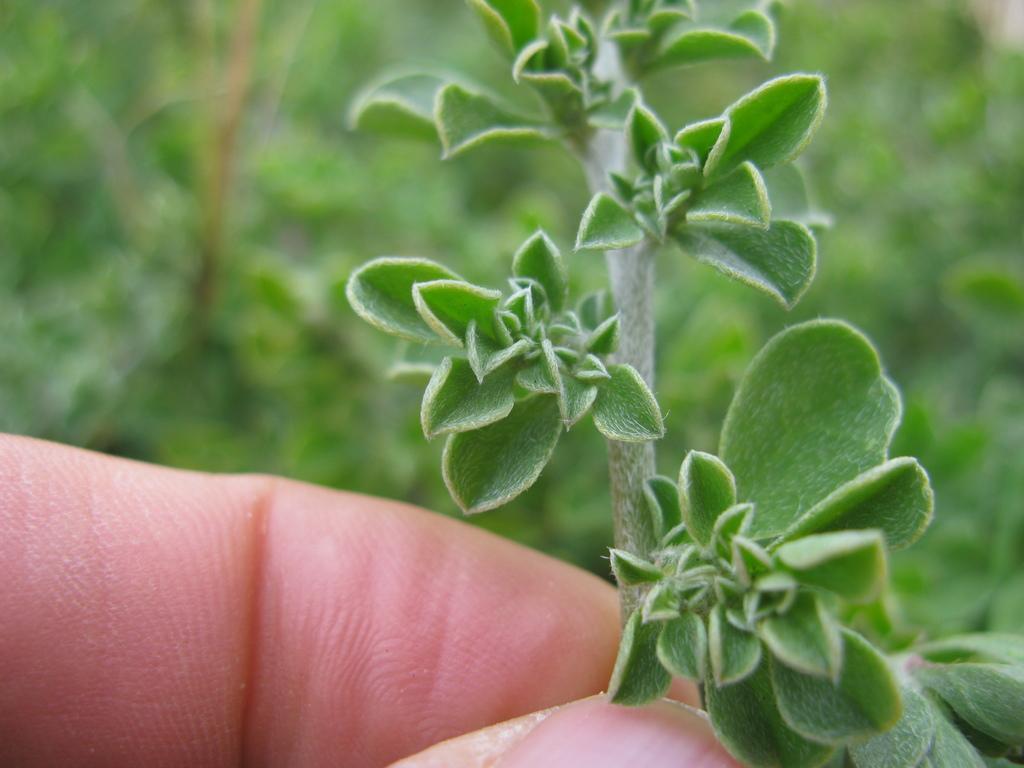Describe this image in one or two sentences. In this picture I can see a plant in the human hand and I can see few plants in the background. 